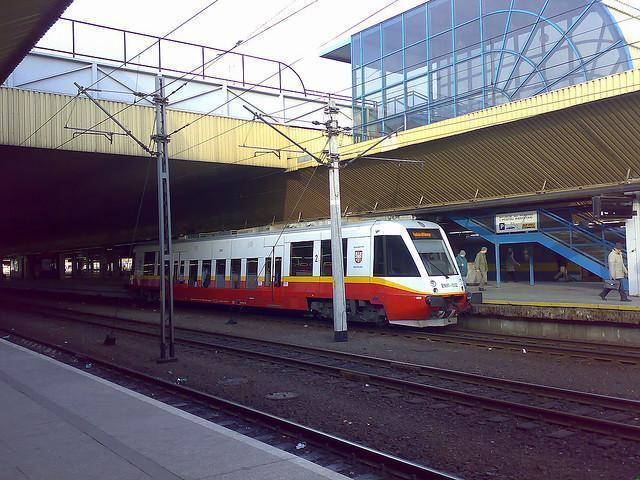How many trains are here?
Give a very brief answer. 1. 